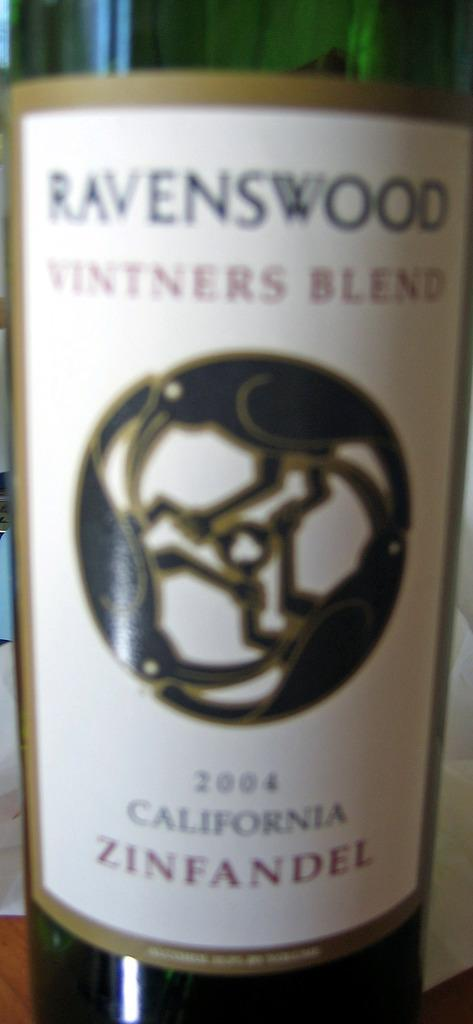Provide a one-sentence caption for the provided image. A bottle of Ravenswood vintners blend Zinfandel from 2004. 